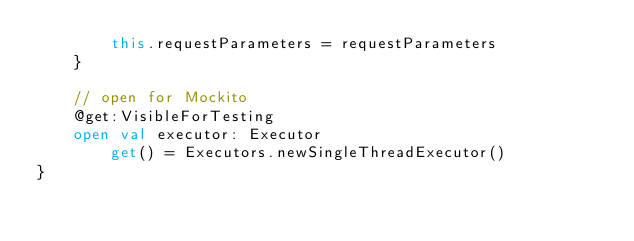<code> <loc_0><loc_0><loc_500><loc_500><_Kotlin_>        this.requestParameters = requestParameters
    }

    // open for Mockito
    @get:VisibleForTesting
    open val executor: Executor
        get() = Executors.newSingleThreadExecutor()
}
</code> 